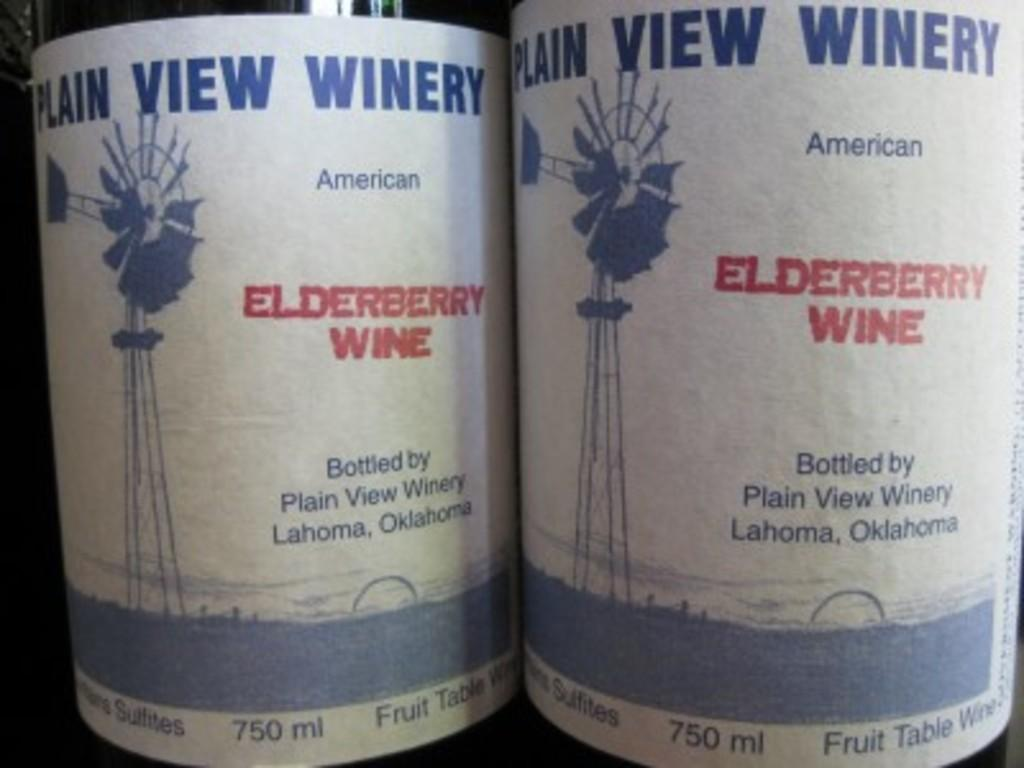<image>
Share a concise interpretation of the image provided. Two bottles of Elderberry Wine from the Plain View Winery. 